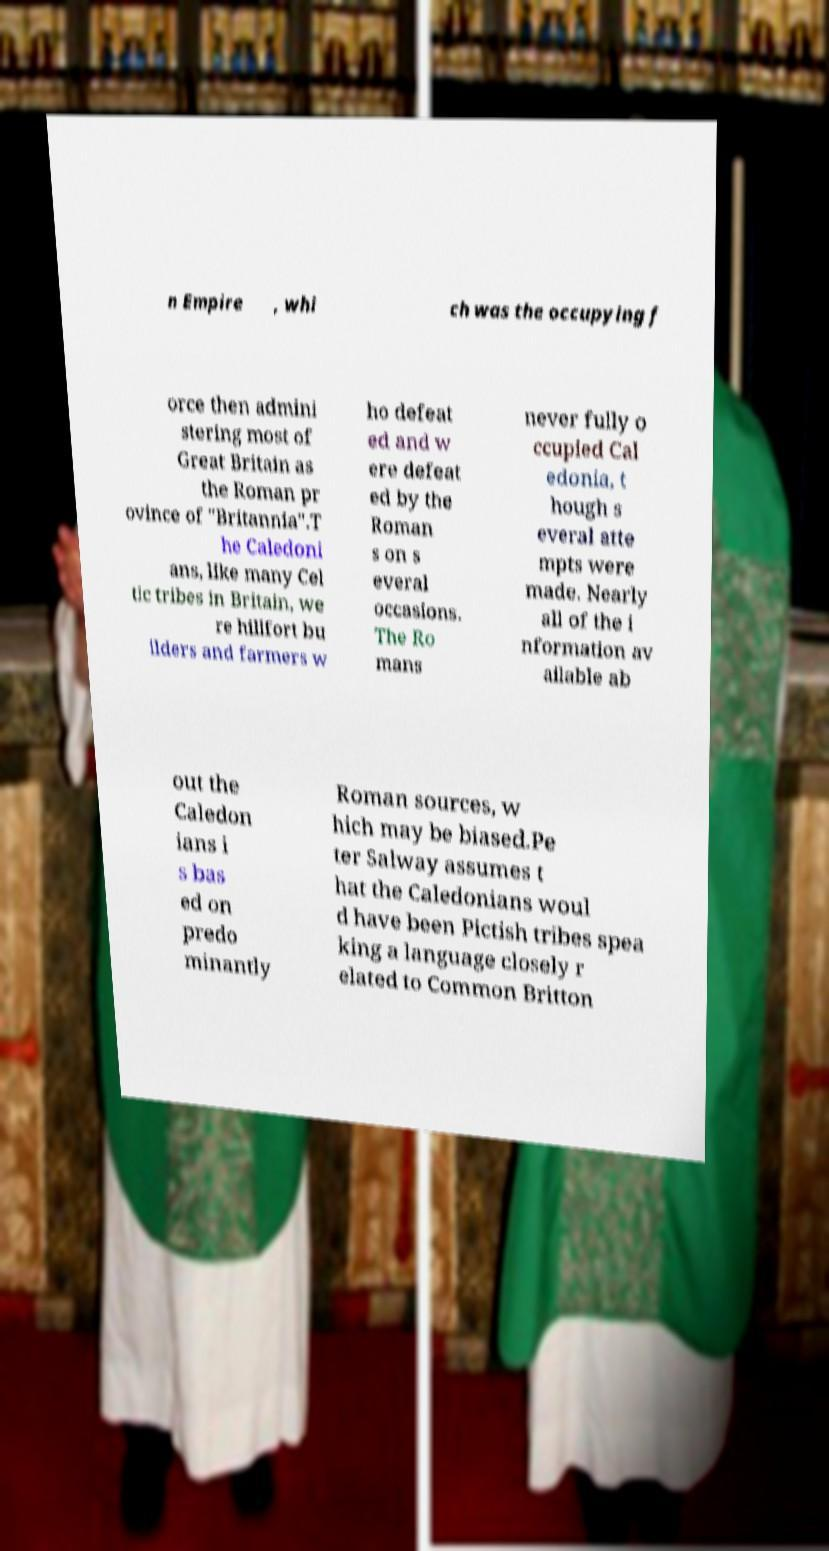Please read and relay the text visible in this image. What does it say? n Empire , whi ch was the occupying f orce then admini stering most of Great Britain as the Roman pr ovince of "Britannia".T he Caledoni ans, like many Cel tic tribes in Britain, we re hillfort bu ilders and farmers w ho defeat ed and w ere defeat ed by the Roman s on s everal occasions. The Ro mans never fully o ccupied Cal edonia, t hough s everal atte mpts were made. Nearly all of the i nformation av ailable ab out the Caledon ians i s bas ed on predo minantly Roman sources, w hich may be biased.Pe ter Salway assumes t hat the Caledonians woul d have been Pictish tribes spea king a language closely r elated to Common Britton 